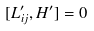Convert formula to latex. <formula><loc_0><loc_0><loc_500><loc_500>[ L _ { i j } ^ { \prime } , H ^ { \prime } ] = 0 \,</formula> 